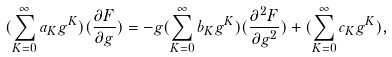<formula> <loc_0><loc_0><loc_500><loc_500>( \sum _ { K = 0 } ^ { \infty } a _ { K } g ^ { K } ) ( \frac { \partial F } { \partial g } ) = - g ( \sum _ { K = 0 } ^ { \infty } b _ { K } g ^ { K } ) ( \frac { \partial ^ { 2 } F } { \partial g ^ { 2 } } ) + ( \sum _ { K = 0 } ^ { \infty } c _ { K } g ^ { K } ) ,</formula> 